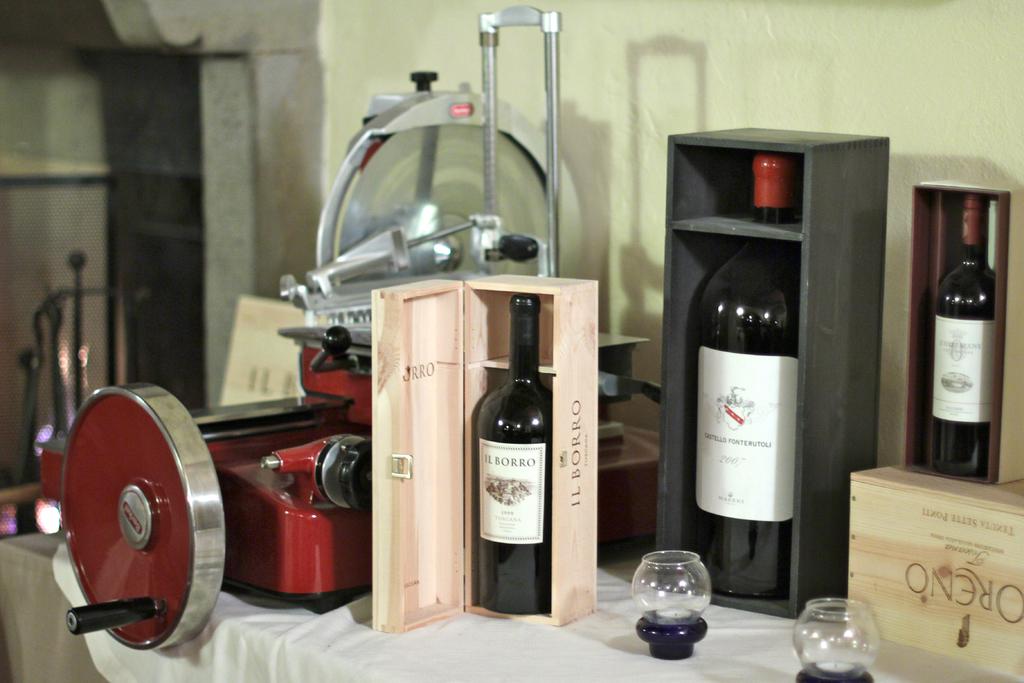What number is written on the large wine bottle?
Your response must be concise. 2007. 